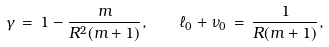<formula> <loc_0><loc_0><loc_500><loc_500>\gamma \, = \, 1 - \frac { m } { R ^ { 2 } ( m + 1 ) } , \quad \ell _ { 0 } + \nu _ { 0 } \, = \, \frac { 1 } { R ( m + 1 ) } ,</formula> 